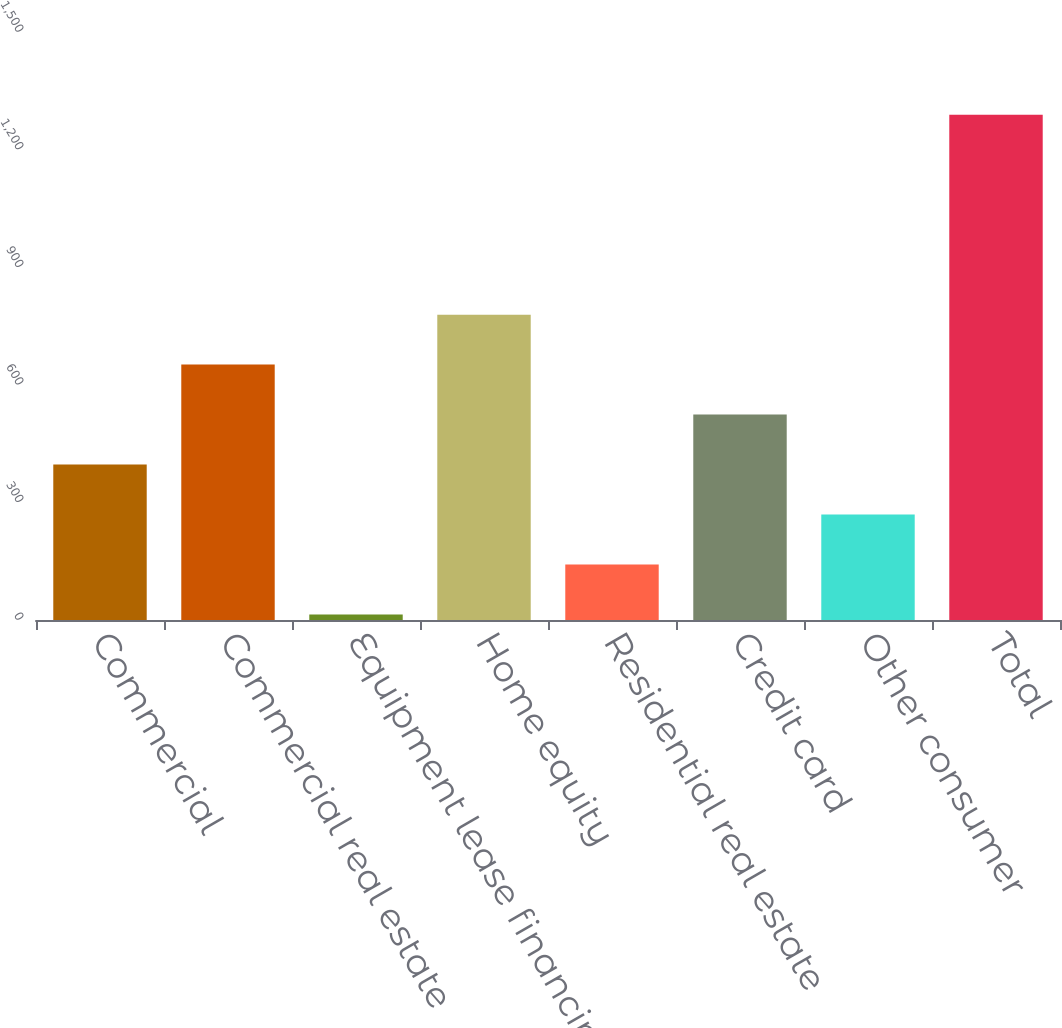Convert chart to OTSL. <chart><loc_0><loc_0><loc_500><loc_500><bar_chart><fcel>Commercial<fcel>Commercial real estate<fcel>Equipment lease financing<fcel>Home equity<fcel>Residential real estate<fcel>Credit card<fcel>Other consumer<fcel>Total<nl><fcel>396.5<fcel>651.5<fcel>14<fcel>779<fcel>141.5<fcel>524<fcel>269<fcel>1289<nl></chart> 